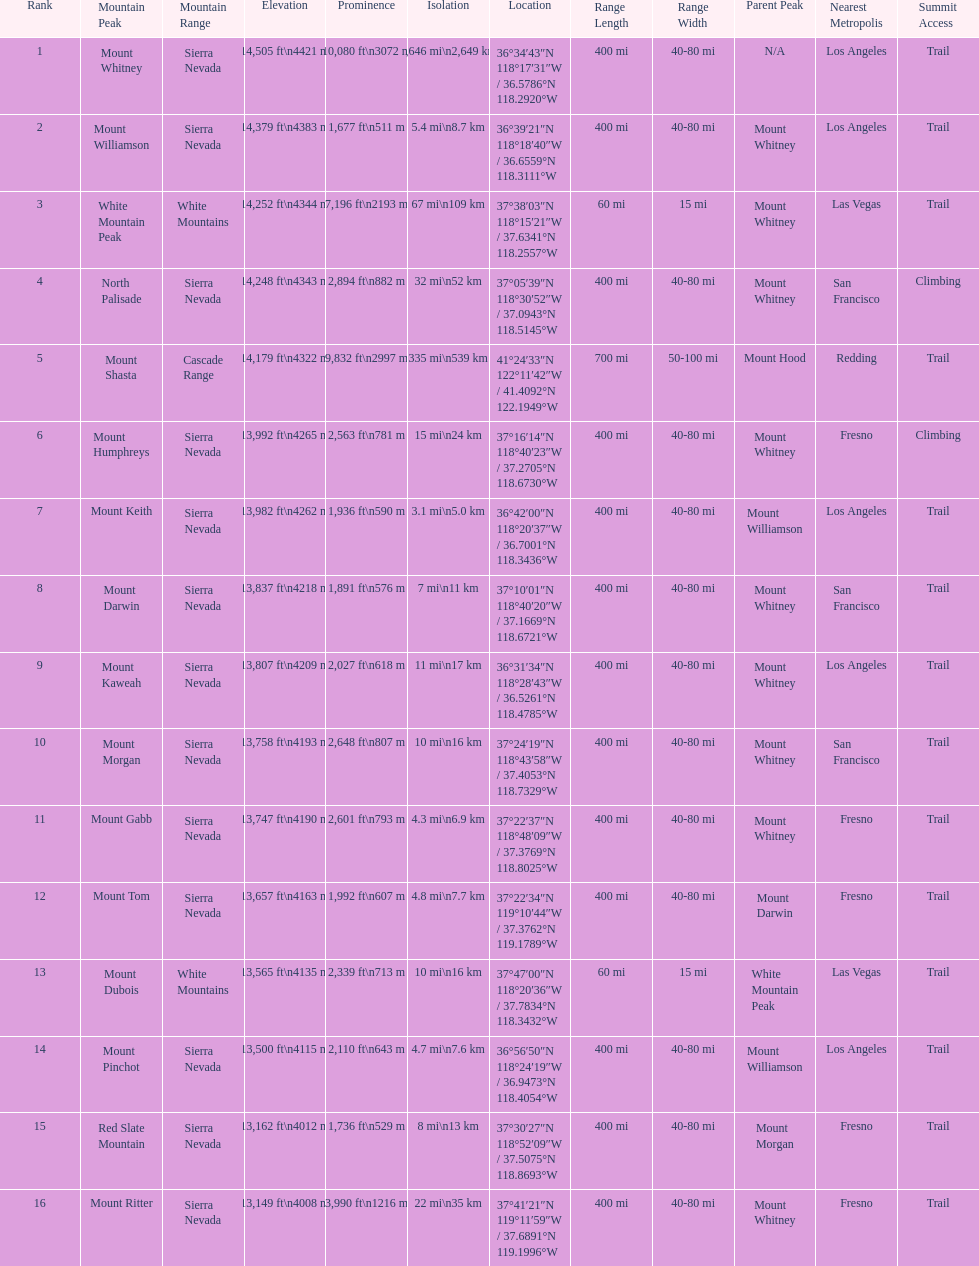Could you parse the entire table? {'header': ['Rank', 'Mountain Peak', 'Mountain Range', 'Elevation', 'Prominence', 'Isolation', 'Location', 'Range Length', 'Range Width', 'Parent Peak', 'Nearest Metropolis', 'Summit Access'], 'rows': [['1', 'Mount Whitney', 'Sierra Nevada', '14,505\xa0ft\\n4421\xa0m', '10,080\xa0ft\\n3072\xa0m', '1,646\xa0mi\\n2,649\xa0km', '36°34′43″N 118°17′31″W\ufeff / \ufeff36.5786°N 118.2920°W', '400 mi', '40-80 mi', 'N/A', 'Los Angeles', 'Trail'], ['2', 'Mount Williamson', 'Sierra Nevada', '14,379\xa0ft\\n4383\xa0m', '1,677\xa0ft\\n511\xa0m', '5.4\xa0mi\\n8.7\xa0km', '36°39′21″N 118°18′40″W\ufeff / \ufeff36.6559°N 118.3111°W', '400 mi', '40-80 mi', 'Mount Whitney', 'Los Angeles', 'Trail'], ['3', 'White Mountain Peak', 'White Mountains', '14,252\xa0ft\\n4344\xa0m', '7,196\xa0ft\\n2193\xa0m', '67\xa0mi\\n109\xa0km', '37°38′03″N 118°15′21″W\ufeff / \ufeff37.6341°N 118.2557°W', '60 mi', '15 mi', 'Mount Whitney', 'Las Vegas', 'Trail'], ['4', 'North Palisade', 'Sierra Nevada', '14,248\xa0ft\\n4343\xa0m', '2,894\xa0ft\\n882\xa0m', '32\xa0mi\\n52\xa0km', '37°05′39″N 118°30′52″W\ufeff / \ufeff37.0943°N 118.5145°W', '400 mi', '40-80 mi', 'Mount Whitney', 'San Francisco', 'Climbing'], ['5', 'Mount Shasta', 'Cascade Range', '14,179\xa0ft\\n4322\xa0m', '9,832\xa0ft\\n2997\xa0m', '335\xa0mi\\n539\xa0km', '41°24′33″N 122°11′42″W\ufeff / \ufeff41.4092°N 122.1949°W', '700 mi', '50-100 mi', 'Mount Hood', 'Redding', 'Trail'], ['6', 'Mount Humphreys', 'Sierra Nevada', '13,992\xa0ft\\n4265\xa0m', '2,563\xa0ft\\n781\xa0m', '15\xa0mi\\n24\xa0km', '37°16′14″N 118°40′23″W\ufeff / \ufeff37.2705°N 118.6730°W', '400 mi', '40-80 mi', 'Mount Whitney', 'Fresno', 'Climbing'], ['7', 'Mount Keith', 'Sierra Nevada', '13,982\xa0ft\\n4262\xa0m', '1,936\xa0ft\\n590\xa0m', '3.1\xa0mi\\n5.0\xa0km', '36°42′00″N 118°20′37″W\ufeff / \ufeff36.7001°N 118.3436°W', '400 mi', '40-80 mi', 'Mount Williamson', 'Los Angeles', 'Trail'], ['8', 'Mount Darwin', 'Sierra Nevada', '13,837\xa0ft\\n4218\xa0m', '1,891\xa0ft\\n576\xa0m', '7\xa0mi\\n11\xa0km', '37°10′01″N 118°40′20″W\ufeff / \ufeff37.1669°N 118.6721°W', '400 mi', '40-80 mi', 'Mount Whitney', 'San Francisco', 'Trail'], ['9', 'Mount Kaweah', 'Sierra Nevada', '13,807\xa0ft\\n4209\xa0m', '2,027\xa0ft\\n618\xa0m', '11\xa0mi\\n17\xa0km', '36°31′34″N 118°28′43″W\ufeff / \ufeff36.5261°N 118.4785°W', '400 mi', '40-80 mi', 'Mount Whitney', 'Los Angeles', 'Trail'], ['10', 'Mount Morgan', 'Sierra Nevada', '13,758\xa0ft\\n4193\xa0m', '2,648\xa0ft\\n807\xa0m', '10\xa0mi\\n16\xa0km', '37°24′19″N 118°43′58″W\ufeff / \ufeff37.4053°N 118.7329°W', '400 mi', '40-80 mi', 'Mount Whitney', 'San Francisco', 'Trail'], ['11', 'Mount Gabb', 'Sierra Nevada', '13,747\xa0ft\\n4190\xa0m', '2,601\xa0ft\\n793\xa0m', '4.3\xa0mi\\n6.9\xa0km', '37°22′37″N 118°48′09″W\ufeff / \ufeff37.3769°N 118.8025°W', '400 mi', '40-80 mi', 'Mount Whitney', 'Fresno', 'Trail'], ['12', 'Mount Tom', 'Sierra Nevada', '13,657\xa0ft\\n4163\xa0m', '1,992\xa0ft\\n607\xa0m', '4.8\xa0mi\\n7.7\xa0km', '37°22′34″N 119°10′44″W\ufeff / \ufeff37.3762°N 119.1789°W', '400 mi', '40-80 mi', 'Mount Darwin', 'Fresno', 'Trail'], ['13', 'Mount Dubois', 'White Mountains', '13,565\xa0ft\\n4135\xa0m', '2,339\xa0ft\\n713\xa0m', '10\xa0mi\\n16\xa0km', '37°47′00″N 118°20′36″W\ufeff / \ufeff37.7834°N 118.3432°W', '60 mi', '15 mi', 'White Mountain Peak', 'Las Vegas', 'Trail'], ['14', 'Mount Pinchot', 'Sierra Nevada', '13,500\xa0ft\\n4115\xa0m', '2,110\xa0ft\\n643\xa0m', '4.7\xa0mi\\n7.6\xa0km', '36°56′50″N 118°24′19″W\ufeff / \ufeff36.9473°N 118.4054°W', '400 mi', '40-80 mi', 'Mount Williamson', 'Los Angeles', 'Trail'], ['15', 'Red Slate Mountain', 'Sierra Nevada', '13,162\xa0ft\\n4012\xa0m', '1,736\xa0ft\\n529\xa0m', '8\xa0mi\\n13\xa0km', '37°30′27″N 118°52′09″W\ufeff / \ufeff37.5075°N 118.8693°W', '400 mi', '40-80 mi', 'Mount Morgan', 'Fresno', 'Trail'], ['16', 'Mount Ritter', 'Sierra Nevada', '13,149\xa0ft\\n4008\xa0m', '3,990\xa0ft\\n1216\xa0m', '22\xa0mi\\n35\xa0km', '37°41′21″N 119°11′59″W\ufeff / \ufeff37.6891°N 119.1996°W', '400 mi', '40-80 mi', 'Mount Whitney', 'Fresno', 'Trail']]} Is the peak of mount keith above or below the peak of north palisade? Below. 